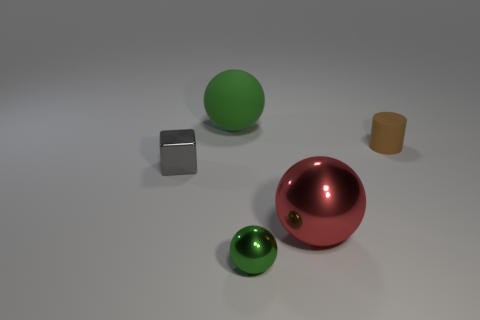Are the small brown cylinder and the large green sphere made of the same material?
Ensure brevity in your answer.  Yes. Are there any small matte things that are behind the small metal thing that is to the right of the tiny metal thing behind the small green thing?
Give a very brief answer. Yes. How many other objects are the same shape as the small gray thing?
Keep it short and to the point. 0. What shape is the thing that is behind the large red shiny sphere and in front of the tiny brown rubber thing?
Offer a terse response. Cube. There is a big thing that is to the right of the matte thing to the left of the large ball that is in front of the small gray thing; what is its color?
Provide a short and direct response. Red. Are there more small objects in front of the small brown rubber object than small gray blocks that are in front of the big shiny sphere?
Provide a short and direct response. Yes. How many other things are the same size as the rubber cylinder?
Your answer should be compact. 2. What size is the other ball that is the same color as the rubber sphere?
Provide a short and direct response. Small. What material is the small thing on the left side of the green sphere in front of the small brown object made of?
Give a very brief answer. Metal. There is a big shiny object; are there any small things behind it?
Your response must be concise. Yes. 